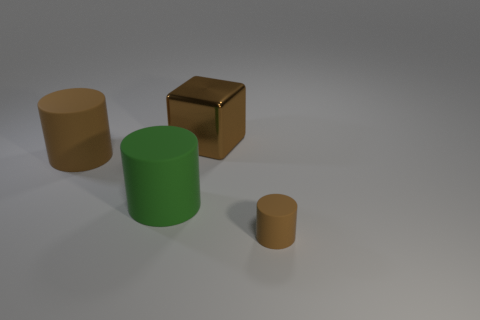Are there any other things that have the same material as the brown block?
Give a very brief answer. No. What number of other objects are there of the same material as the big brown cube?
Ensure brevity in your answer.  0. What number of big brown metal cubes are left of the green object?
Ensure brevity in your answer.  0. How many balls are big matte objects or green things?
Your answer should be very brief. 0. What size is the brown object that is both in front of the shiny thing and on the left side of the small brown cylinder?
Your response must be concise. Large. What number of other things are the same color as the large metal cube?
Make the answer very short. 2. Do the small cylinder and the brown cylinder that is left of the brown metallic object have the same material?
Your answer should be very brief. Yes. How many objects are brown matte cylinders on the right side of the big brown matte object or tiny blue rubber cylinders?
Your answer should be very brief. 1. The object that is both in front of the big brown rubber cylinder and on the right side of the large green matte thing has what shape?
Your answer should be compact. Cylinder. Is there any other thing that has the same size as the brown cube?
Offer a very short reply. Yes. 